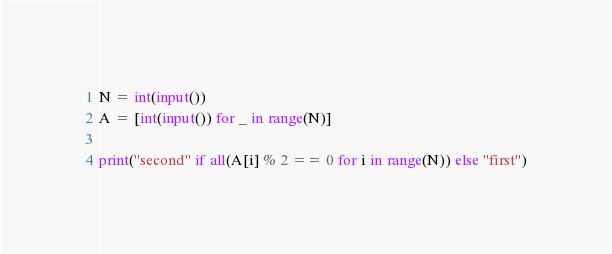<code> <loc_0><loc_0><loc_500><loc_500><_Python_>N = int(input())
A = [int(input()) for _ in range(N)]

print("second" if all(A[i] % 2 == 0 for i in range(N)) else "first")
</code> 